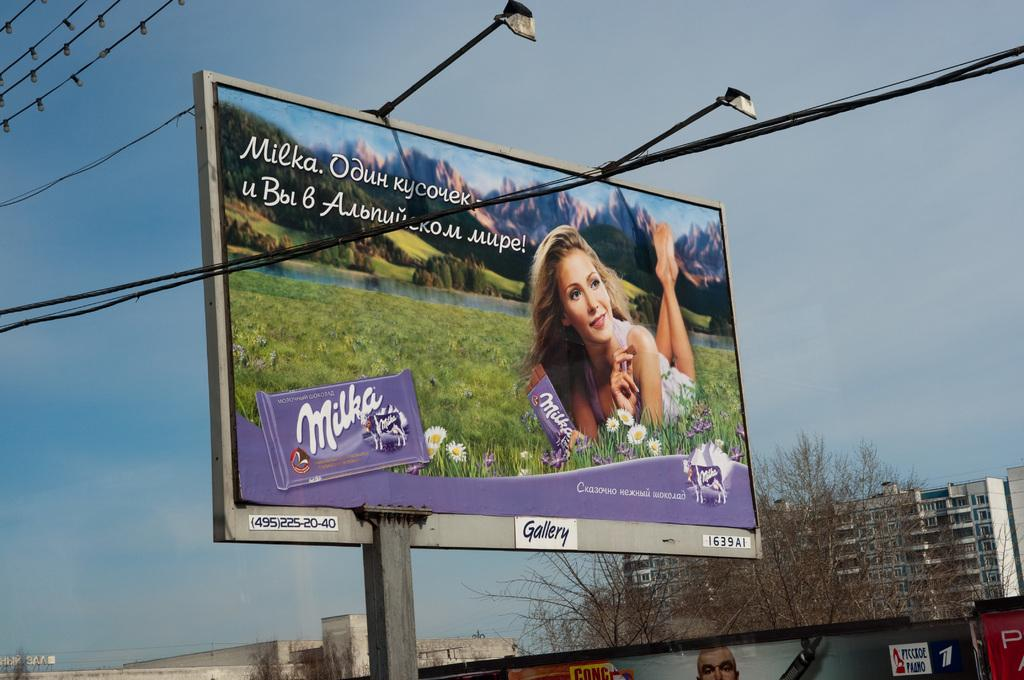<image>
Present a compact description of the photo's key features. A giant billboard featuring a woman holding a Milka chocolate bar. 